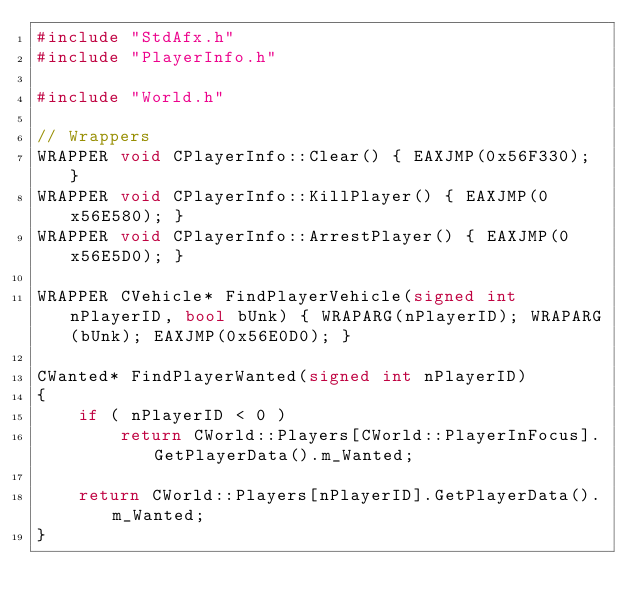Convert code to text. <code><loc_0><loc_0><loc_500><loc_500><_C++_>#include "StdAfx.h"
#include "PlayerInfo.h"

#include "World.h"

// Wrappers
WRAPPER void CPlayerInfo::Clear() { EAXJMP(0x56F330); }
WRAPPER void CPlayerInfo::KillPlayer() { EAXJMP(0x56E580); }
WRAPPER void CPlayerInfo::ArrestPlayer() { EAXJMP(0x56E5D0); }

WRAPPER CVehicle* FindPlayerVehicle(signed int nPlayerID, bool bUnk) { WRAPARG(nPlayerID); WRAPARG(bUnk); EAXJMP(0x56E0D0); }

CWanted* FindPlayerWanted(signed int nPlayerID)
{
	if ( nPlayerID < 0 )
		return CWorld::Players[CWorld::PlayerInFocus].GetPlayerData().m_Wanted;

	return CWorld::Players[nPlayerID].GetPlayerData().m_Wanted;
}</code> 